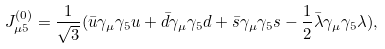Convert formula to latex. <formula><loc_0><loc_0><loc_500><loc_500>J _ { \mu 5 } ^ { ( 0 ) } = { \frac { 1 } { \sqrt { 3 } } } ( { \bar { u } } \gamma _ { \mu } \gamma _ { 5 } u + { \bar { d } } \gamma _ { \mu } \gamma _ { 5 } d + { \bar { s } } \gamma _ { \mu } \gamma _ { 5 } s - { \frac { 1 } { 2 } } { \bar { \lambda } } \gamma _ { \mu } \gamma _ { 5 } \lambda ) ,</formula> 